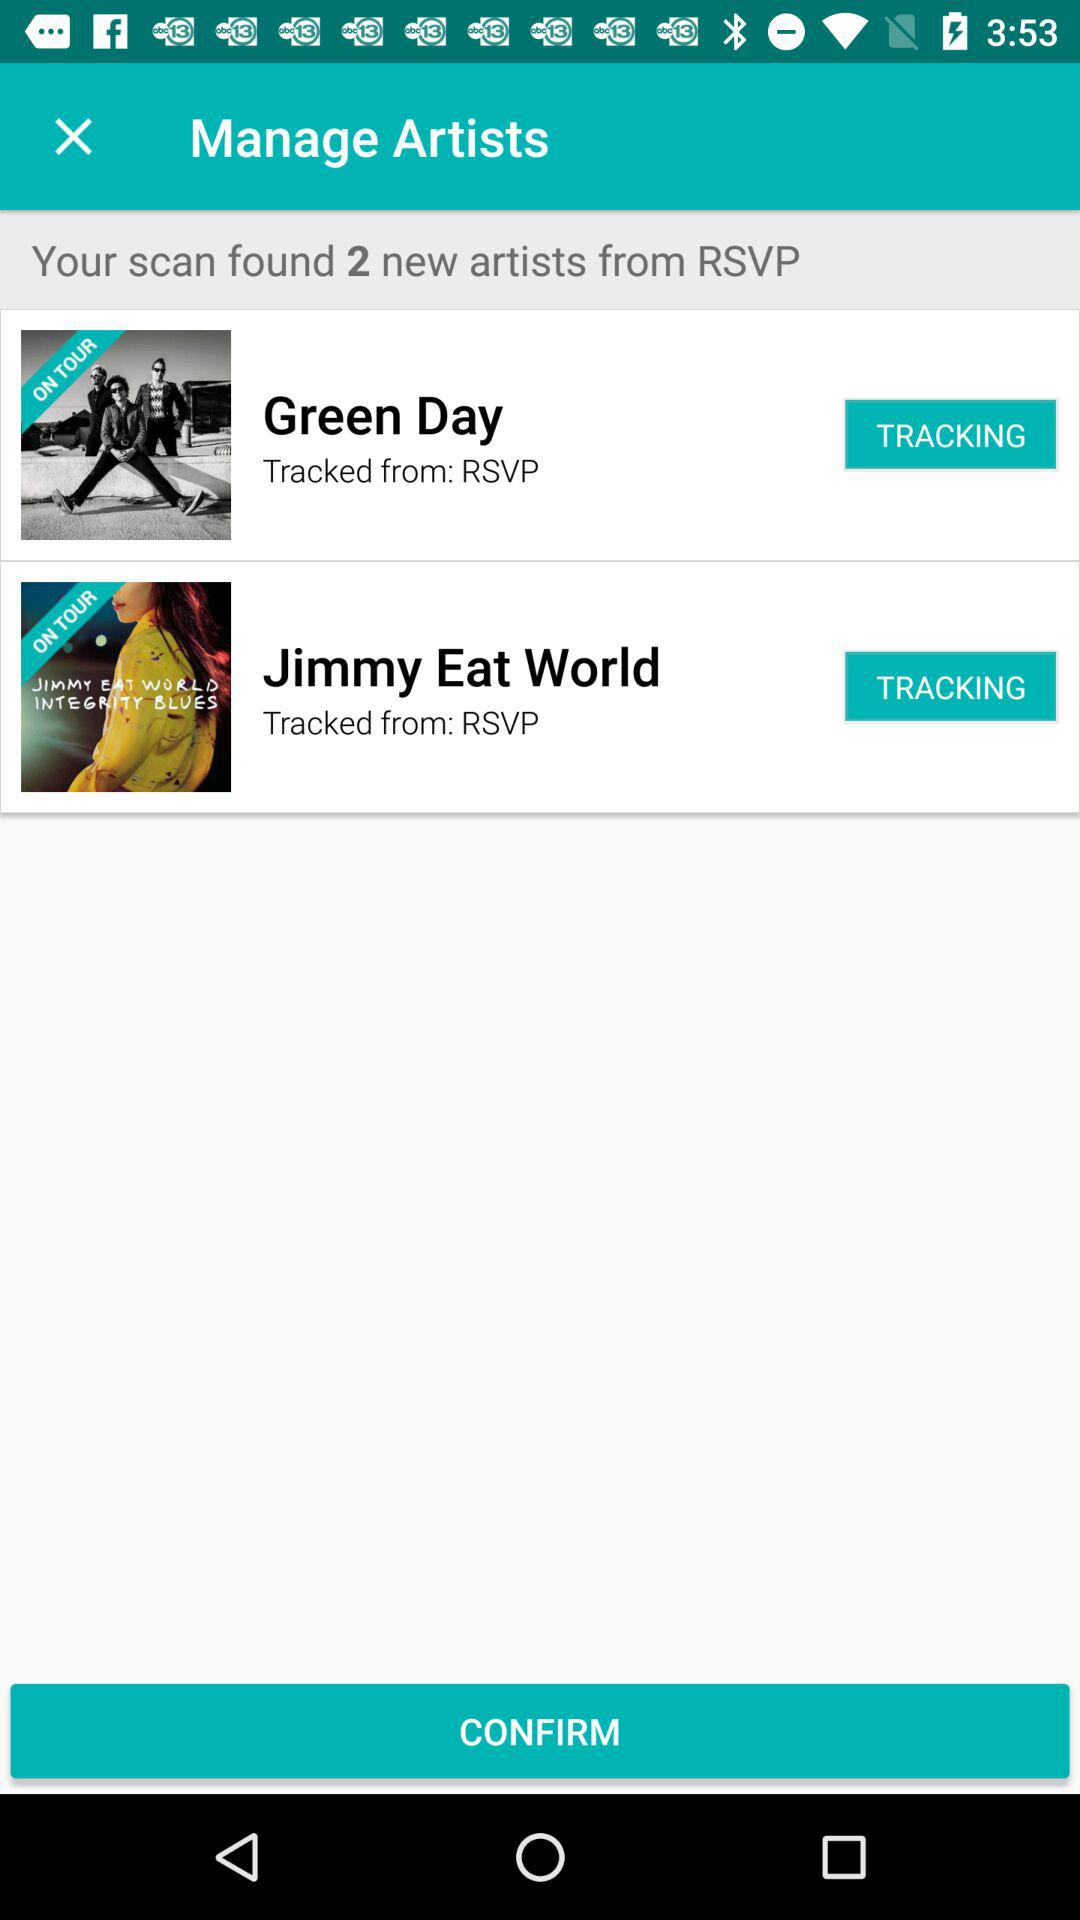What can this app likely help a user with based on the 'TRACKING' button next to the artists? The 'TRACKING' button suggests that the app provides a feature for users to follow or keep an eye on their preferred artists. This likely includes updates on concert dates, ticket availability, new music releases, and other related news to ensure fans don't miss any important updates from artists they enjoy. 